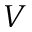<formula> <loc_0><loc_0><loc_500><loc_500>V</formula> 